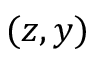Convert formula to latex. <formula><loc_0><loc_0><loc_500><loc_500>( z , y )</formula> 